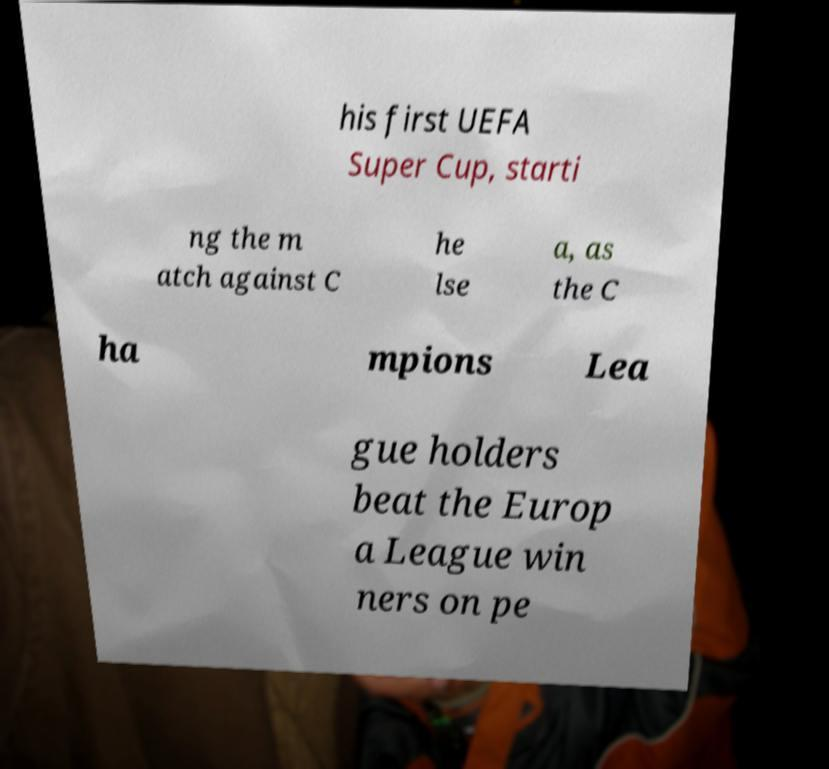Can you read and provide the text displayed in the image?This photo seems to have some interesting text. Can you extract and type it out for me? his first UEFA Super Cup, starti ng the m atch against C he lse a, as the C ha mpions Lea gue holders beat the Europ a League win ners on pe 